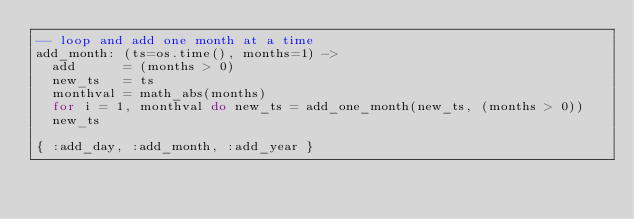<code> <loc_0><loc_0><loc_500><loc_500><_MoonScript_>-- loop and add one month at a time
add_month: (ts=os.time(), months=1) ->
  add      = (months > 0)
  new_ts   = ts
  monthval = math_abs(months)
  for i = 1, monthval do new_ts = add_one_month(new_ts, (months > 0))
  new_ts

{ :add_day, :add_month, :add_year }
</code> 